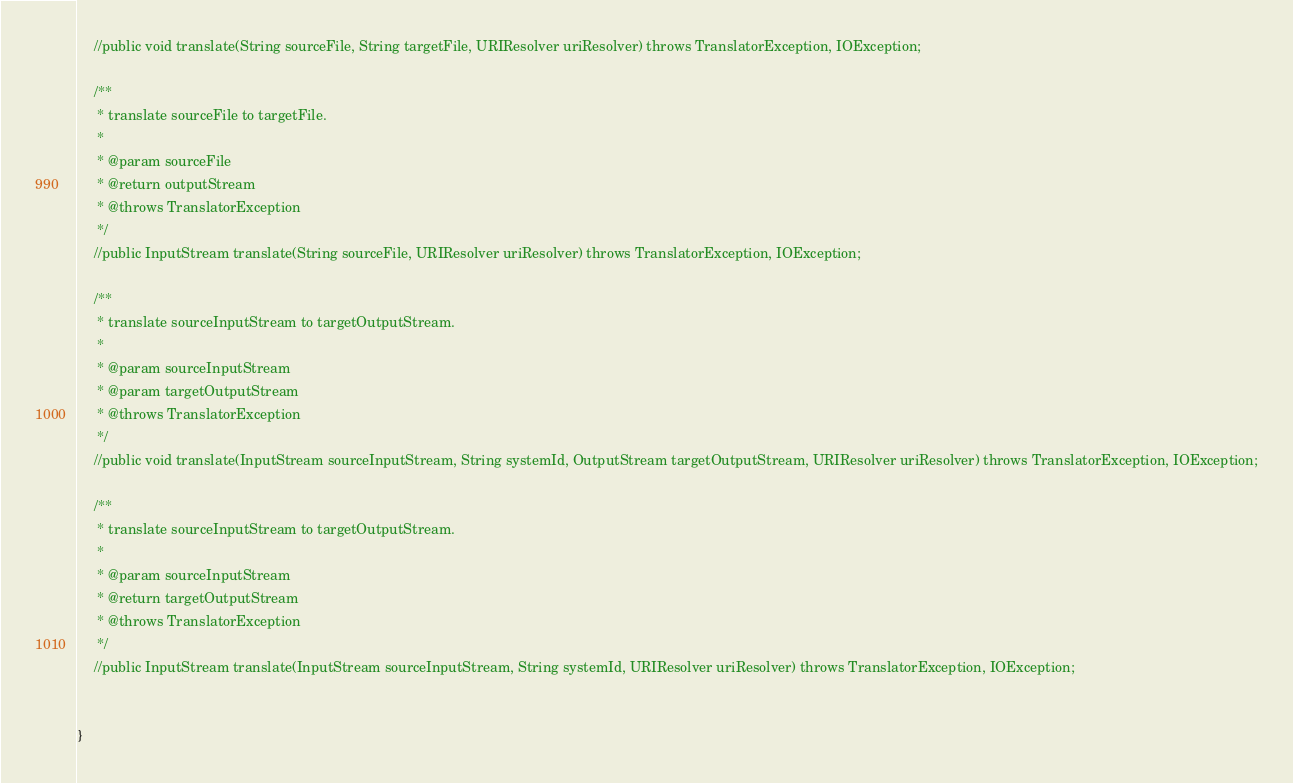<code> <loc_0><loc_0><loc_500><loc_500><_Java_>    //public void translate(String sourceFile, String targetFile, URIResolver uriResolver) throws TranslatorException, IOException;

    /**
     * translate sourceFile to targetFile.
     * 
     * @param sourceFile
     * @return outputStream
     * @throws TranslatorException
     */
    //public InputStream translate(String sourceFile, URIResolver uriResolver) throws TranslatorException, IOException;

    /**
     * translate sourceInputStream to targetOutputStream.
     * 
     * @param sourceInputStream
     * @param targetOutputStream
     * @throws TranslatorException
     */
    //public void translate(InputStream sourceInputStream, String systemId, OutputStream targetOutputStream, URIResolver uriResolver) throws TranslatorException, IOException;

    /**
     * translate sourceInputStream to targetOutputStream.
     * 
     * @param sourceInputStream
     * @return targetOutputStream
     * @throws TranslatorException
     */
    //public InputStream translate(InputStream sourceInputStream, String systemId, URIResolver uriResolver) throws TranslatorException, IOException;

        
}
</code> 